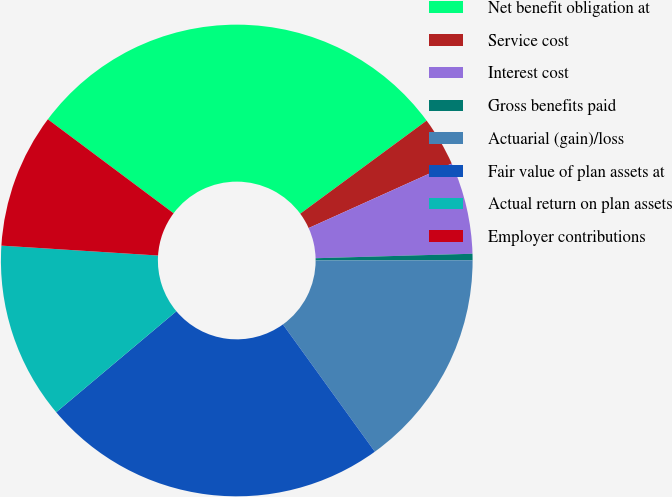Convert chart. <chart><loc_0><loc_0><loc_500><loc_500><pie_chart><fcel>Net benefit obligation at<fcel>Service cost<fcel>Interest cost<fcel>Gross benefits paid<fcel>Actuarial (gain)/loss<fcel>Fair value of plan assets at<fcel>Actual return on plan assets<fcel>Employer contributions<nl><fcel>29.68%<fcel>3.36%<fcel>6.29%<fcel>0.44%<fcel>15.06%<fcel>23.83%<fcel>12.13%<fcel>9.21%<nl></chart> 